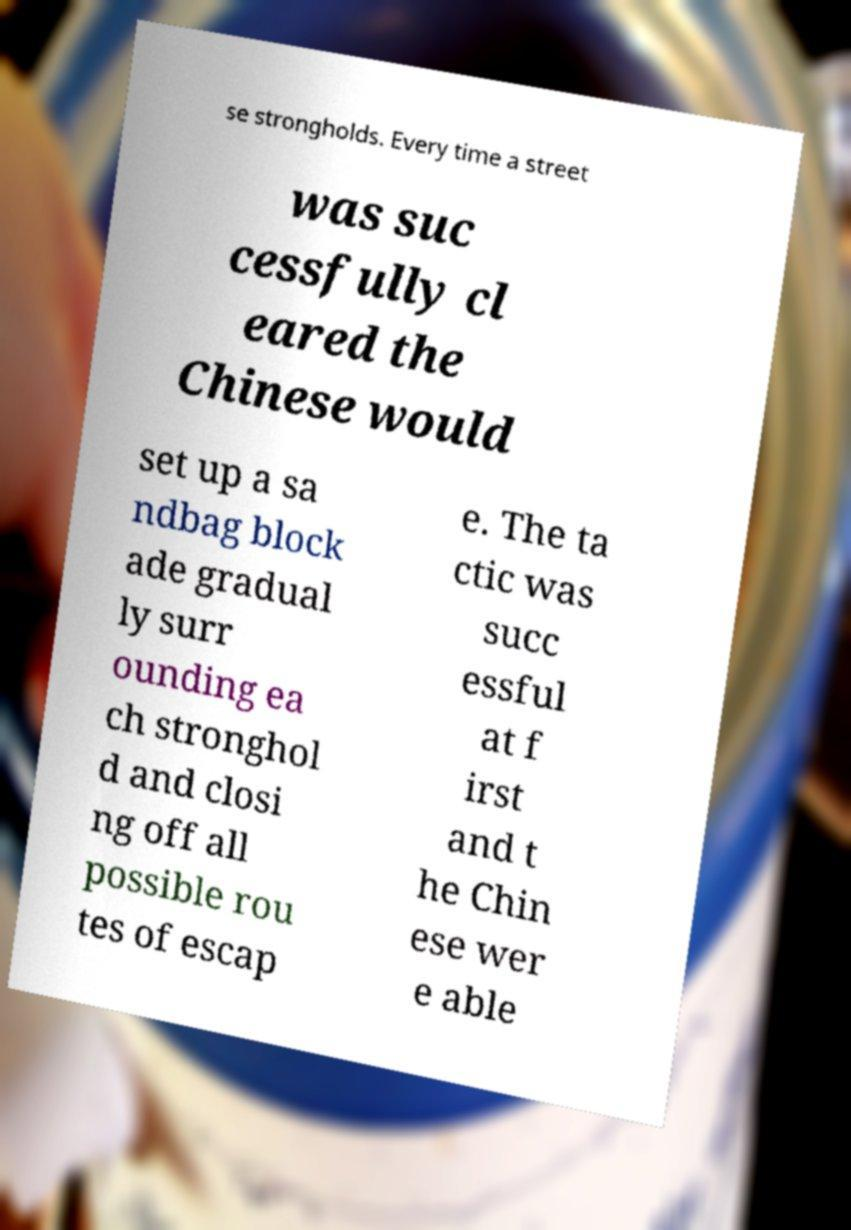Could you extract and type out the text from this image? se strongholds. Every time a street was suc cessfully cl eared the Chinese would set up a sa ndbag block ade gradual ly surr ounding ea ch stronghol d and closi ng off all possible rou tes of escap e. The ta ctic was succ essful at f irst and t he Chin ese wer e able 